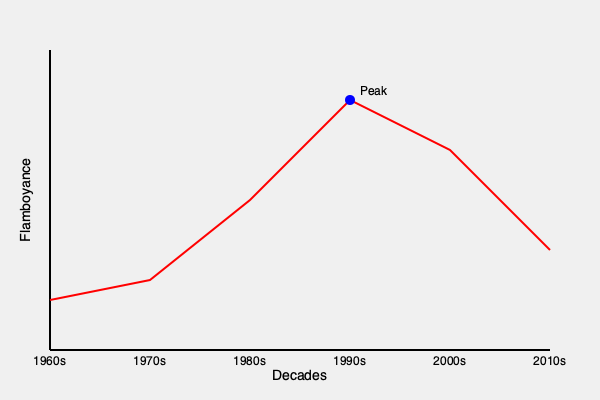Based on the graph depicting the evolution of British comedy fashion trends, which decade marked the peak of flamboyance in comedic attire? To determine the decade with the peak flamboyance in British comedy fashion, we need to analyze the graph step-by-step:

1. The x-axis represents decades from the 1960s to the 2010s.
2. The y-axis represents the level of flamboyance in comedic attire.
3. The red line shows the trend of flamboyance over time.
4. We can observe that:
   a. The line starts relatively low in the 1960s.
   b. It gradually increases through the 1970s.
   c. There's a sharp rise in the 1980s.
   d. The line reaches its highest point in the 1990s.
   e. After the 1990s, there's a decline in flamboyance.
5. The blue dot on the graph explicitly marks the peak point.
6. This peak point aligns with the 1990s on the x-axis.

Therefore, based on the information provided in the graph, the 1990s marked the peak of flamboyance in British comedy fashion trends.
Answer: 1990s 